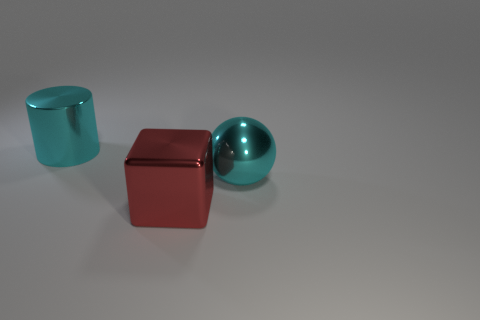How many other things are there of the same shape as the red object?
Make the answer very short. 0. There is a object that is the same color as the metal ball; what is its material?
Give a very brief answer. Metal. What number of big metallic things have the same color as the big metallic sphere?
Keep it short and to the point. 1. The cylinder that is the same material as the large cyan sphere is what color?
Offer a terse response. Cyan. Are there any purple rubber spheres of the same size as the shiny cube?
Your answer should be compact. No. Is the number of large metallic spheres behind the large metallic cylinder greater than the number of large objects that are to the right of the large cyan sphere?
Make the answer very short. No. Is the object right of the large red object made of the same material as the thing that is to the left of the big red metal cube?
Offer a very short reply. Yes. There is a red metallic thing that is the same size as the cyan metal ball; what is its shape?
Offer a very short reply. Cube. Are there any other red shiny things that have the same shape as the red thing?
Your answer should be very brief. No. There is a shiny object on the right side of the big red shiny block; does it have the same color as the object that is on the left side of the big metal cube?
Ensure brevity in your answer.  Yes. 